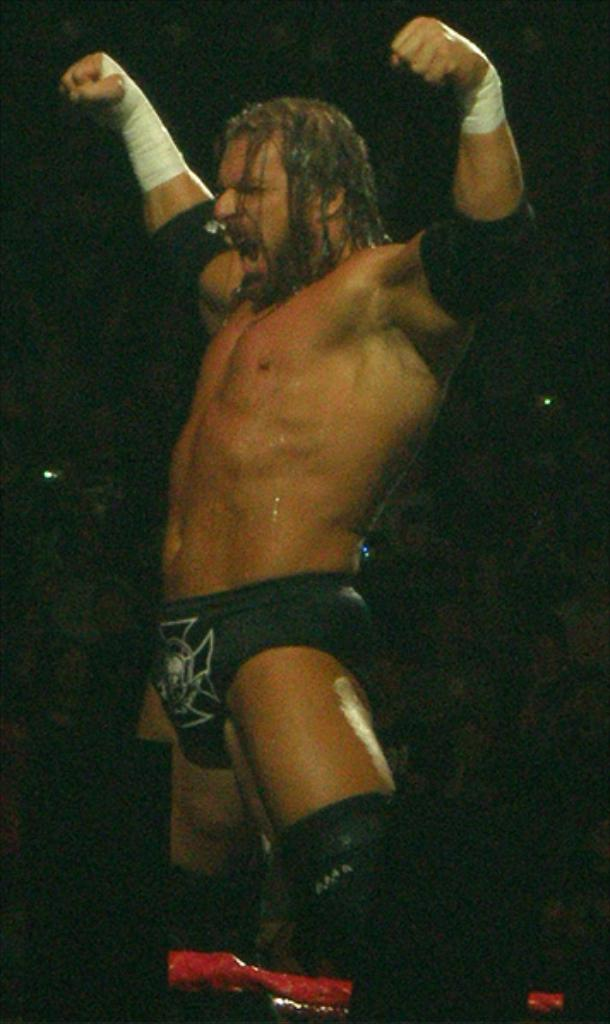What is the main subject of the image? There is a person standing in the image. What is the person wearing? The person is wearing a black dress. Can you describe the background of the image? The background of the image is dark. What type of card is the person holding in the image? There is no card present in the image; the person is not holding anything. What color is the dress that the gate is wearing in the image? There is no gate or dress worn by a gate in the image. 